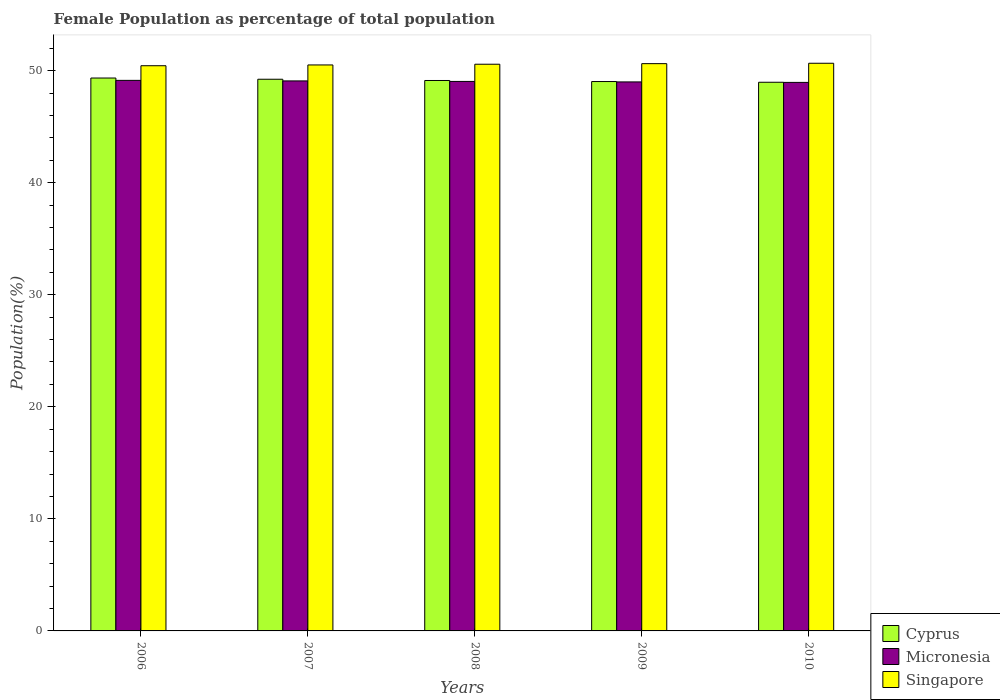How many groups of bars are there?
Your response must be concise. 5. Are the number of bars per tick equal to the number of legend labels?
Your response must be concise. Yes. How many bars are there on the 5th tick from the right?
Keep it short and to the point. 3. In how many cases, is the number of bars for a given year not equal to the number of legend labels?
Make the answer very short. 0. What is the female population in in Micronesia in 2010?
Give a very brief answer. 48.95. Across all years, what is the maximum female population in in Cyprus?
Offer a terse response. 49.34. Across all years, what is the minimum female population in in Singapore?
Keep it short and to the point. 50.43. In which year was the female population in in Micronesia minimum?
Offer a terse response. 2010. What is the total female population in in Cyprus in the graph?
Make the answer very short. 245.67. What is the difference between the female population in in Cyprus in 2009 and that in 2010?
Make the answer very short. 0.06. What is the difference between the female population in in Cyprus in 2008 and the female population in in Micronesia in 2010?
Give a very brief answer. 0.17. What is the average female population in in Singapore per year?
Offer a terse response. 50.56. In the year 2008, what is the difference between the female population in in Singapore and female population in in Micronesia?
Your answer should be very brief. 1.53. What is the ratio of the female population in in Singapore in 2006 to that in 2007?
Your answer should be very brief. 1. Is the difference between the female population in in Singapore in 2008 and 2009 greater than the difference between the female population in in Micronesia in 2008 and 2009?
Your answer should be compact. No. What is the difference between the highest and the second highest female population in in Micronesia?
Provide a short and direct response. 0.05. What is the difference between the highest and the lowest female population in in Singapore?
Give a very brief answer. 0.22. What does the 3rd bar from the left in 2010 represents?
Offer a very short reply. Singapore. What does the 2nd bar from the right in 2006 represents?
Ensure brevity in your answer.  Micronesia. Is it the case that in every year, the sum of the female population in in Cyprus and female population in in Micronesia is greater than the female population in in Singapore?
Give a very brief answer. Yes. Are all the bars in the graph horizontal?
Keep it short and to the point. No. Are the values on the major ticks of Y-axis written in scientific E-notation?
Offer a very short reply. No. Does the graph contain grids?
Offer a terse response. No. Where does the legend appear in the graph?
Your answer should be compact. Bottom right. What is the title of the graph?
Your response must be concise. Female Population as percentage of total population. Does "Croatia" appear as one of the legend labels in the graph?
Your answer should be very brief. No. What is the label or title of the Y-axis?
Give a very brief answer. Population(%). What is the Population(%) of Cyprus in 2006?
Provide a short and direct response. 49.34. What is the Population(%) of Micronesia in 2006?
Ensure brevity in your answer.  49.13. What is the Population(%) of Singapore in 2006?
Your answer should be compact. 50.43. What is the Population(%) in Cyprus in 2007?
Your response must be concise. 49.23. What is the Population(%) of Micronesia in 2007?
Give a very brief answer. 49.08. What is the Population(%) of Singapore in 2007?
Offer a terse response. 50.5. What is the Population(%) in Cyprus in 2008?
Provide a succinct answer. 49.12. What is the Population(%) in Micronesia in 2008?
Offer a terse response. 49.03. What is the Population(%) in Singapore in 2008?
Your response must be concise. 50.57. What is the Population(%) in Cyprus in 2009?
Offer a terse response. 49.02. What is the Population(%) in Micronesia in 2009?
Your response must be concise. 48.99. What is the Population(%) in Singapore in 2009?
Provide a short and direct response. 50.62. What is the Population(%) in Cyprus in 2010?
Give a very brief answer. 48.96. What is the Population(%) in Micronesia in 2010?
Your response must be concise. 48.95. What is the Population(%) in Singapore in 2010?
Keep it short and to the point. 50.66. Across all years, what is the maximum Population(%) in Cyprus?
Provide a short and direct response. 49.34. Across all years, what is the maximum Population(%) of Micronesia?
Offer a very short reply. 49.13. Across all years, what is the maximum Population(%) of Singapore?
Your answer should be compact. 50.66. Across all years, what is the minimum Population(%) of Cyprus?
Provide a short and direct response. 48.96. Across all years, what is the minimum Population(%) in Micronesia?
Give a very brief answer. 48.95. Across all years, what is the minimum Population(%) in Singapore?
Offer a very short reply. 50.43. What is the total Population(%) in Cyprus in the graph?
Your response must be concise. 245.67. What is the total Population(%) in Micronesia in the graph?
Ensure brevity in your answer.  245.18. What is the total Population(%) of Singapore in the graph?
Your response must be concise. 252.78. What is the difference between the Population(%) of Cyprus in 2006 and that in 2007?
Your answer should be compact. 0.11. What is the difference between the Population(%) of Micronesia in 2006 and that in 2007?
Keep it short and to the point. 0.05. What is the difference between the Population(%) of Singapore in 2006 and that in 2007?
Keep it short and to the point. -0.07. What is the difference between the Population(%) in Cyprus in 2006 and that in 2008?
Ensure brevity in your answer.  0.22. What is the difference between the Population(%) in Micronesia in 2006 and that in 2008?
Your response must be concise. 0.09. What is the difference between the Population(%) of Singapore in 2006 and that in 2008?
Your answer should be very brief. -0.13. What is the difference between the Population(%) in Cyprus in 2006 and that in 2009?
Your answer should be very brief. 0.31. What is the difference between the Population(%) in Micronesia in 2006 and that in 2009?
Give a very brief answer. 0.14. What is the difference between the Population(%) of Singapore in 2006 and that in 2009?
Ensure brevity in your answer.  -0.19. What is the difference between the Population(%) of Cyprus in 2006 and that in 2010?
Offer a very short reply. 0.38. What is the difference between the Population(%) in Micronesia in 2006 and that in 2010?
Provide a short and direct response. 0.18. What is the difference between the Population(%) in Singapore in 2006 and that in 2010?
Ensure brevity in your answer.  -0.22. What is the difference between the Population(%) in Micronesia in 2007 and that in 2008?
Your response must be concise. 0.05. What is the difference between the Population(%) of Singapore in 2007 and that in 2008?
Ensure brevity in your answer.  -0.06. What is the difference between the Population(%) in Cyprus in 2007 and that in 2009?
Your answer should be very brief. 0.21. What is the difference between the Population(%) of Micronesia in 2007 and that in 2009?
Make the answer very short. 0.09. What is the difference between the Population(%) in Singapore in 2007 and that in 2009?
Provide a succinct answer. -0.12. What is the difference between the Population(%) of Cyprus in 2007 and that in 2010?
Provide a succinct answer. 0.27. What is the difference between the Population(%) of Micronesia in 2007 and that in 2010?
Your answer should be very brief. 0.13. What is the difference between the Population(%) of Singapore in 2007 and that in 2010?
Keep it short and to the point. -0.15. What is the difference between the Population(%) in Cyprus in 2008 and that in 2009?
Ensure brevity in your answer.  0.09. What is the difference between the Population(%) of Micronesia in 2008 and that in 2009?
Give a very brief answer. 0.04. What is the difference between the Population(%) of Singapore in 2008 and that in 2009?
Keep it short and to the point. -0.05. What is the difference between the Population(%) in Cyprus in 2008 and that in 2010?
Give a very brief answer. 0.16. What is the difference between the Population(%) in Micronesia in 2008 and that in 2010?
Your response must be concise. 0.09. What is the difference between the Population(%) in Singapore in 2008 and that in 2010?
Make the answer very short. -0.09. What is the difference between the Population(%) in Cyprus in 2009 and that in 2010?
Provide a succinct answer. 0.06. What is the difference between the Population(%) in Micronesia in 2009 and that in 2010?
Your response must be concise. 0.04. What is the difference between the Population(%) of Singapore in 2009 and that in 2010?
Your answer should be compact. -0.03. What is the difference between the Population(%) of Cyprus in 2006 and the Population(%) of Micronesia in 2007?
Provide a succinct answer. 0.26. What is the difference between the Population(%) in Cyprus in 2006 and the Population(%) in Singapore in 2007?
Offer a terse response. -1.17. What is the difference between the Population(%) of Micronesia in 2006 and the Population(%) of Singapore in 2007?
Give a very brief answer. -1.38. What is the difference between the Population(%) in Cyprus in 2006 and the Population(%) in Micronesia in 2008?
Provide a succinct answer. 0.3. What is the difference between the Population(%) in Cyprus in 2006 and the Population(%) in Singapore in 2008?
Offer a terse response. -1.23. What is the difference between the Population(%) of Micronesia in 2006 and the Population(%) of Singapore in 2008?
Ensure brevity in your answer.  -1.44. What is the difference between the Population(%) in Cyprus in 2006 and the Population(%) in Micronesia in 2009?
Ensure brevity in your answer.  0.35. What is the difference between the Population(%) in Cyprus in 2006 and the Population(%) in Singapore in 2009?
Offer a very short reply. -1.28. What is the difference between the Population(%) of Micronesia in 2006 and the Population(%) of Singapore in 2009?
Offer a very short reply. -1.49. What is the difference between the Population(%) in Cyprus in 2006 and the Population(%) in Micronesia in 2010?
Your response must be concise. 0.39. What is the difference between the Population(%) of Cyprus in 2006 and the Population(%) of Singapore in 2010?
Offer a terse response. -1.32. What is the difference between the Population(%) in Micronesia in 2006 and the Population(%) in Singapore in 2010?
Give a very brief answer. -1.53. What is the difference between the Population(%) of Cyprus in 2007 and the Population(%) of Micronesia in 2008?
Provide a short and direct response. 0.19. What is the difference between the Population(%) of Cyprus in 2007 and the Population(%) of Singapore in 2008?
Offer a very short reply. -1.34. What is the difference between the Population(%) of Micronesia in 2007 and the Population(%) of Singapore in 2008?
Your answer should be very brief. -1.49. What is the difference between the Population(%) of Cyprus in 2007 and the Population(%) of Micronesia in 2009?
Ensure brevity in your answer.  0.24. What is the difference between the Population(%) of Cyprus in 2007 and the Population(%) of Singapore in 2009?
Provide a succinct answer. -1.39. What is the difference between the Population(%) of Micronesia in 2007 and the Population(%) of Singapore in 2009?
Your answer should be very brief. -1.54. What is the difference between the Population(%) in Cyprus in 2007 and the Population(%) in Micronesia in 2010?
Offer a terse response. 0.28. What is the difference between the Population(%) in Cyprus in 2007 and the Population(%) in Singapore in 2010?
Give a very brief answer. -1.43. What is the difference between the Population(%) of Micronesia in 2007 and the Population(%) of Singapore in 2010?
Give a very brief answer. -1.58. What is the difference between the Population(%) in Cyprus in 2008 and the Population(%) in Micronesia in 2009?
Keep it short and to the point. 0.13. What is the difference between the Population(%) in Cyprus in 2008 and the Population(%) in Singapore in 2009?
Offer a terse response. -1.5. What is the difference between the Population(%) of Micronesia in 2008 and the Population(%) of Singapore in 2009?
Provide a short and direct response. -1.59. What is the difference between the Population(%) of Cyprus in 2008 and the Population(%) of Micronesia in 2010?
Keep it short and to the point. 0.17. What is the difference between the Population(%) of Cyprus in 2008 and the Population(%) of Singapore in 2010?
Provide a short and direct response. -1.54. What is the difference between the Population(%) of Micronesia in 2008 and the Population(%) of Singapore in 2010?
Make the answer very short. -1.62. What is the difference between the Population(%) in Cyprus in 2009 and the Population(%) in Micronesia in 2010?
Offer a very short reply. 0.08. What is the difference between the Population(%) in Cyprus in 2009 and the Population(%) in Singapore in 2010?
Make the answer very short. -1.63. What is the difference between the Population(%) in Micronesia in 2009 and the Population(%) in Singapore in 2010?
Make the answer very short. -1.66. What is the average Population(%) in Cyprus per year?
Your answer should be compact. 49.13. What is the average Population(%) of Micronesia per year?
Your answer should be compact. 49.04. What is the average Population(%) of Singapore per year?
Offer a terse response. 50.56. In the year 2006, what is the difference between the Population(%) of Cyprus and Population(%) of Micronesia?
Offer a very short reply. 0.21. In the year 2006, what is the difference between the Population(%) in Cyprus and Population(%) in Singapore?
Keep it short and to the point. -1.1. In the year 2006, what is the difference between the Population(%) in Micronesia and Population(%) in Singapore?
Provide a short and direct response. -1.31. In the year 2007, what is the difference between the Population(%) in Cyprus and Population(%) in Micronesia?
Your response must be concise. 0.15. In the year 2007, what is the difference between the Population(%) in Cyprus and Population(%) in Singapore?
Your response must be concise. -1.28. In the year 2007, what is the difference between the Population(%) of Micronesia and Population(%) of Singapore?
Ensure brevity in your answer.  -1.42. In the year 2008, what is the difference between the Population(%) in Cyprus and Population(%) in Micronesia?
Ensure brevity in your answer.  0.08. In the year 2008, what is the difference between the Population(%) in Cyprus and Population(%) in Singapore?
Offer a very short reply. -1.45. In the year 2008, what is the difference between the Population(%) in Micronesia and Population(%) in Singapore?
Your answer should be very brief. -1.53. In the year 2009, what is the difference between the Population(%) of Cyprus and Population(%) of Micronesia?
Make the answer very short. 0.03. In the year 2009, what is the difference between the Population(%) in Cyprus and Population(%) in Singapore?
Keep it short and to the point. -1.6. In the year 2009, what is the difference between the Population(%) in Micronesia and Population(%) in Singapore?
Offer a very short reply. -1.63. In the year 2010, what is the difference between the Population(%) of Cyprus and Population(%) of Micronesia?
Your answer should be compact. 0.01. In the year 2010, what is the difference between the Population(%) of Cyprus and Population(%) of Singapore?
Provide a succinct answer. -1.7. In the year 2010, what is the difference between the Population(%) in Micronesia and Population(%) in Singapore?
Ensure brevity in your answer.  -1.71. What is the ratio of the Population(%) in Cyprus in 2006 to that in 2008?
Give a very brief answer. 1. What is the ratio of the Population(%) of Singapore in 2006 to that in 2008?
Give a very brief answer. 1. What is the ratio of the Population(%) of Cyprus in 2006 to that in 2009?
Your answer should be compact. 1.01. What is the ratio of the Population(%) in Micronesia in 2006 to that in 2009?
Provide a succinct answer. 1. What is the ratio of the Population(%) of Singapore in 2006 to that in 2009?
Offer a very short reply. 1. What is the ratio of the Population(%) in Cyprus in 2006 to that in 2010?
Offer a terse response. 1.01. What is the ratio of the Population(%) in Singapore in 2006 to that in 2010?
Make the answer very short. 1. What is the ratio of the Population(%) in Micronesia in 2007 to that in 2008?
Your answer should be very brief. 1. What is the ratio of the Population(%) of Singapore in 2007 to that in 2008?
Offer a very short reply. 1. What is the ratio of the Population(%) in Cyprus in 2007 to that in 2009?
Give a very brief answer. 1. What is the ratio of the Population(%) of Micronesia in 2007 to that in 2009?
Offer a terse response. 1. What is the ratio of the Population(%) of Cyprus in 2007 to that in 2010?
Make the answer very short. 1.01. What is the ratio of the Population(%) in Micronesia in 2007 to that in 2010?
Give a very brief answer. 1. What is the ratio of the Population(%) in Cyprus in 2008 to that in 2009?
Your answer should be compact. 1. What is the ratio of the Population(%) in Micronesia in 2008 to that in 2009?
Make the answer very short. 1. What is the ratio of the Population(%) in Singapore in 2008 to that in 2010?
Give a very brief answer. 1. What is the ratio of the Population(%) of Cyprus in 2009 to that in 2010?
Your answer should be compact. 1. What is the ratio of the Population(%) in Micronesia in 2009 to that in 2010?
Make the answer very short. 1. What is the difference between the highest and the second highest Population(%) of Cyprus?
Offer a terse response. 0.11. What is the difference between the highest and the second highest Population(%) in Micronesia?
Ensure brevity in your answer.  0.05. What is the difference between the highest and the second highest Population(%) in Singapore?
Offer a very short reply. 0.03. What is the difference between the highest and the lowest Population(%) of Cyprus?
Your answer should be compact. 0.38. What is the difference between the highest and the lowest Population(%) in Micronesia?
Make the answer very short. 0.18. What is the difference between the highest and the lowest Population(%) of Singapore?
Make the answer very short. 0.22. 